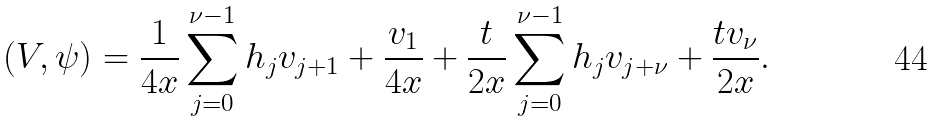Convert formula to latex. <formula><loc_0><loc_0><loc_500><loc_500>\left ( V , \psi \right ) = \frac { 1 } { 4 x } \sum _ { j = 0 } ^ { \nu - 1 } h _ { j } v _ { j + 1 } + \frac { v _ { 1 } } { 4 x } + \frac { t } { 2 x } \sum _ { j = 0 } ^ { \nu - 1 } h _ { j } v _ { j + \nu } + \frac { t v _ { \nu } } { 2 x } .</formula> 